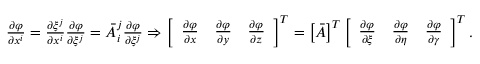<formula> <loc_0><loc_0><loc_500><loc_500>\begin{array} { r } { \frac { \partial \varphi } { \partial x ^ { i } } = \frac { \partial \xi ^ { j } } { \partial x ^ { i } } \frac { \partial \varphi } { \partial \xi ^ { j } } = \bar { A } _ { i } ^ { j } \frac { \partial \varphi } { \partial \xi ^ { j } } \Rightarrow \left [ \begin{array} { l l l } { \frac { \partial \varphi } { \partial x } } & { \frac { \partial \varphi } { \partial y } } & { \frac { \partial \varphi } { \partial z } } \end{array} \right ] ^ { T } = \left [ \bar { A } \right ] ^ { T } \left [ \begin{array} { l l l } { \frac { \partial \varphi } { \partial \xi } } & { \frac { \partial \varphi } { \partial \eta } } & { \frac { \partial \varphi } { \partial \gamma } } \end{array} \right ] ^ { T } . } \end{array}</formula> 